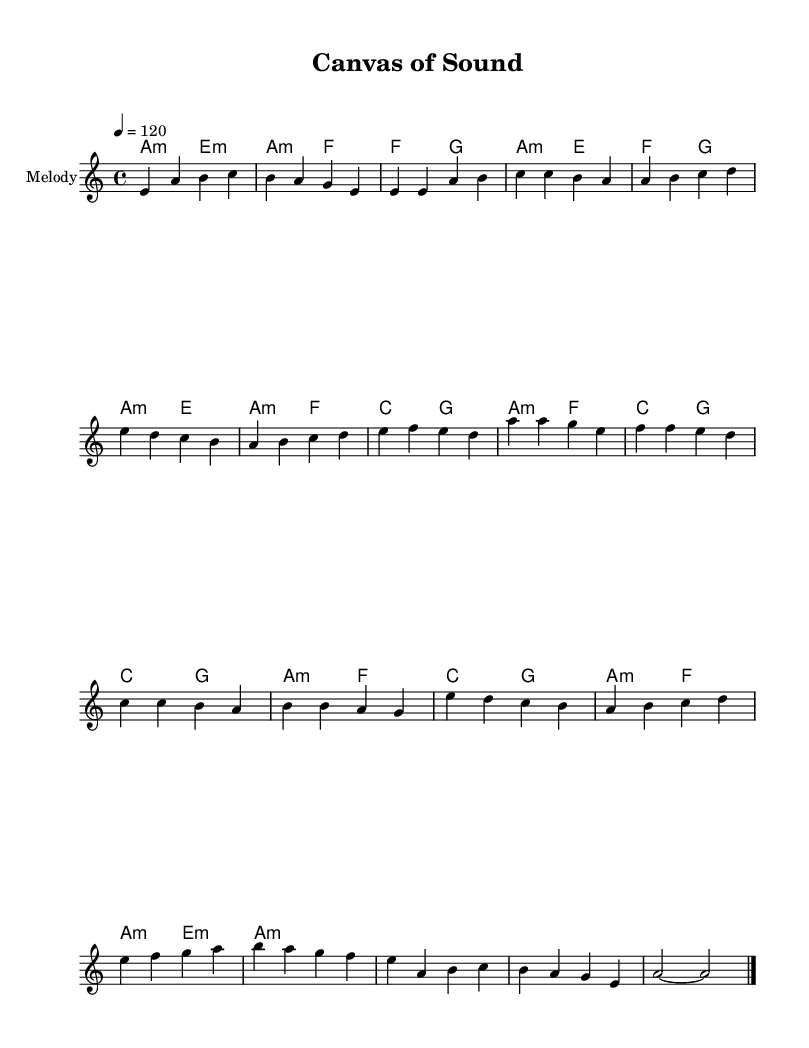What is the key signature of this music? The key signature indicates that the piece is in A minor, which is the relative minor of C major and has no sharps or flats. This can be identified by looking at the initial part of the sheet music where the key signature is notated.
Answer: A minor What is the time signature of this music? The time signature is 4/4, which means there are four beats in each measure and the quarter note gets one beat. This is typically indicated at the beginning of the score, following the key signature.
Answer: 4/4 What is the tempo marking of this piece? The tempo marking is set at 120 beats per minute, reflected as “4 = 120” in the score. This informs the performer of the speed at which the piece should be played.
Answer: 120 How many measures are in the Chorus section? The Chorus section contains four measures, as evident from counting the groups of bars marked in that part of the sheet music.
Answer: 4 What type of harmony is primarily used in the Intro? The harmony used in the Intro is based on A minor. This can be discerned from the chord names indicated in the harmony part at the beginning of the score.
Answer: A minor What is a unique characteristic of the structure found in K-Pop? A unique characteristic of K-Pop is the incorporation of a bridge between the chorus and outro, which provides contrast and variety in the overall song structure. This can be identified by the distinct section labeled as "Bridge" in the melody.
Answer: Bridge 